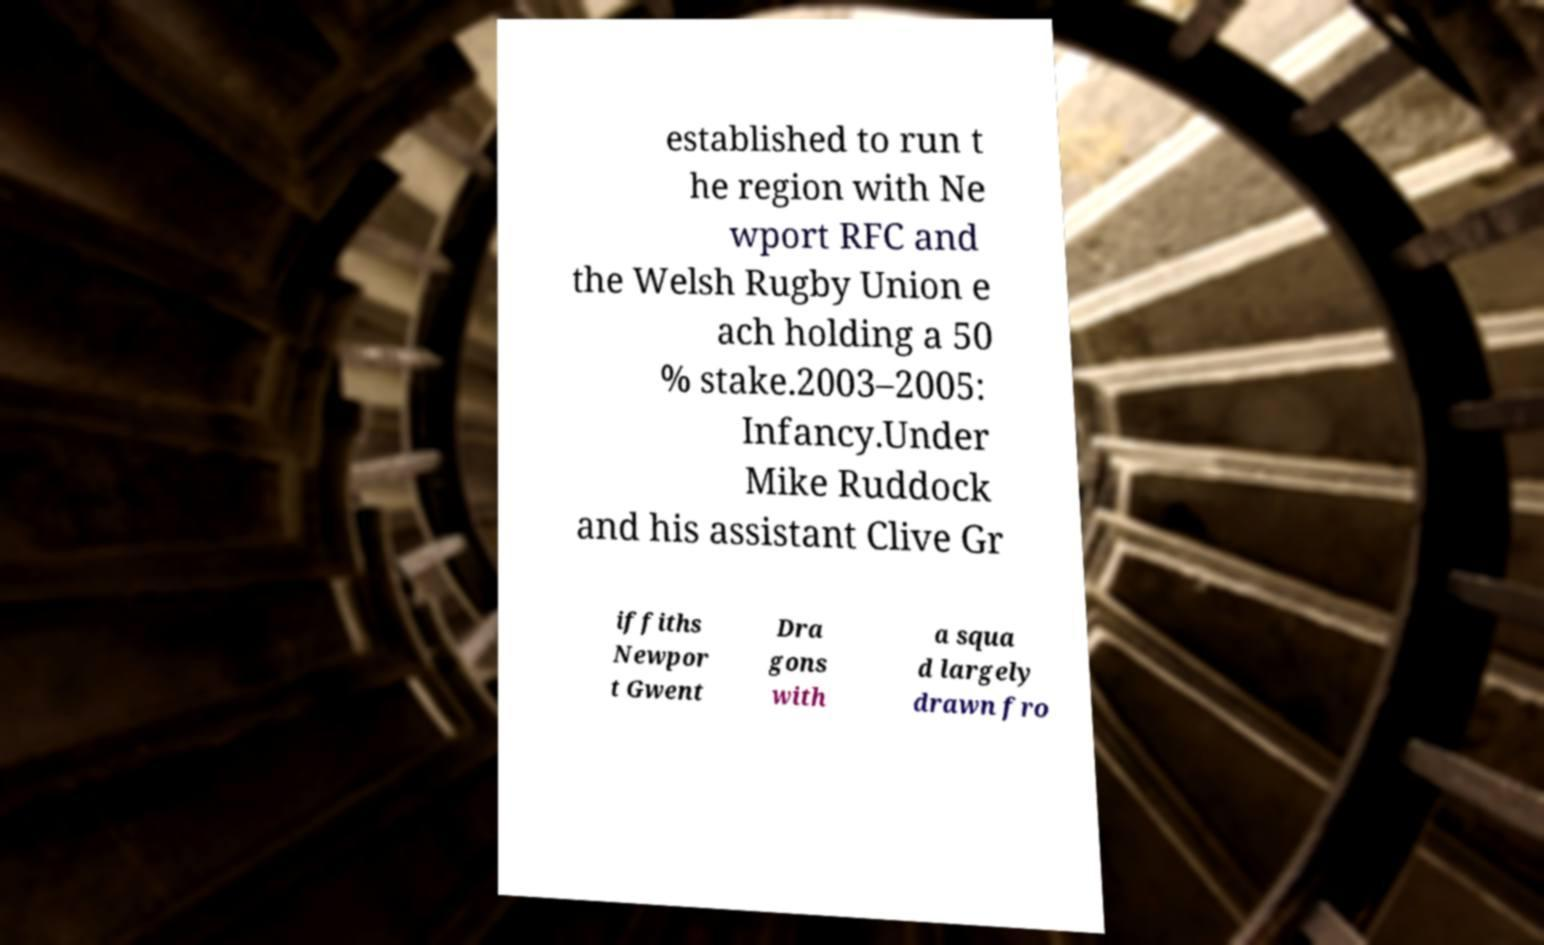What messages or text are displayed in this image? I need them in a readable, typed format. established to run t he region with Ne wport RFC and the Welsh Rugby Union e ach holding a 50 % stake.2003–2005: Infancy.Under Mike Ruddock and his assistant Clive Gr iffiths Newpor t Gwent Dra gons with a squa d largely drawn fro 